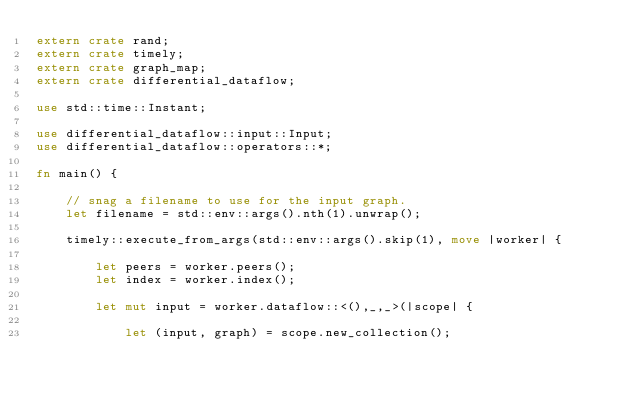Convert code to text. <code><loc_0><loc_0><loc_500><loc_500><_Rust_>extern crate rand;
extern crate timely;
extern crate graph_map;
extern crate differential_dataflow;

use std::time::Instant;

use differential_dataflow::input::Input;
use differential_dataflow::operators::*;

fn main() {

    // snag a filename to use for the input graph.
    let filename = std::env::args().nth(1).unwrap();

    timely::execute_from_args(std::env::args().skip(1), move |worker| {

        let peers = worker.peers();
        let index = worker.index();

        let mut input = worker.dataflow::<(),_,_>(|scope| {

            let (input, graph) = scope.new_collection();
</code> 